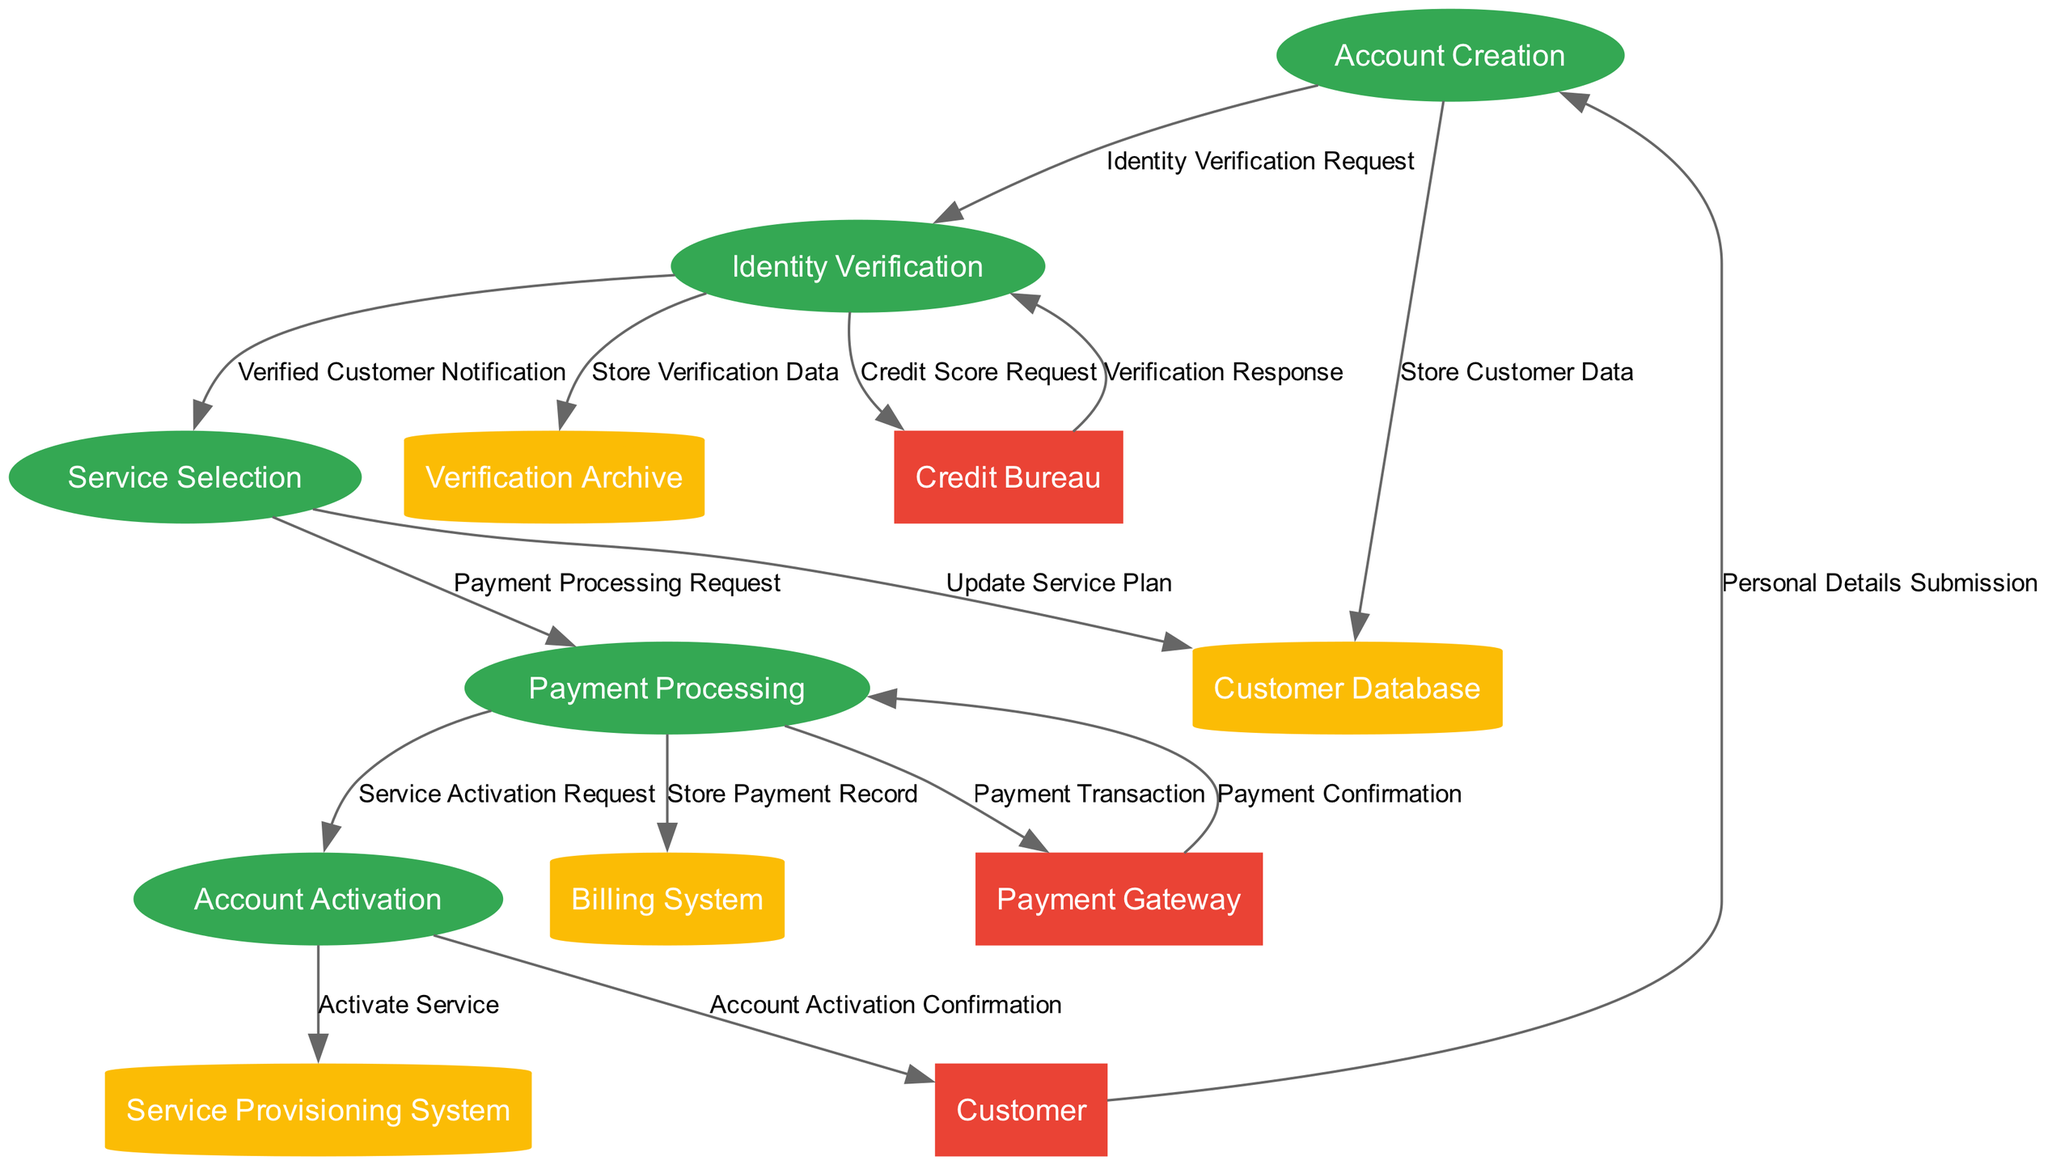What is the first process in the onboarding flow? The first process in the diagram is indicated as the starting node, which is labeled "Account Creation." This process receives input from the external entity "Customer" for account setup.
Answer: Account Creation How many external entities are present in the diagram? By counting the nodes shaped like rectangles that represent external entities, we find three: "Customer," "Payment Gateway," and "Credit Bureau." Thus, the total count is three.
Answer: 3 What type of data store is used to manage payment records? The data store dedicated to managing payment records is described as "Billing System" and has a cylinder shape in the diagram, which signifies a data store.
Answer: Billing System What is the output of the "Payment Processing" process? The output of the "Payment Processing" process is two-fold: it sends a "Payment Confirmation" back to the "Payment Gateway," and also stores the payment transaction details in the "Billing System," indicating multiple outputs.
Answer: Payment Confirmation and Store Payment Record Which process follows the identity verification? Following the "Identity Verification" process, the next process is the "Service Selection," which only occurs if the identity verification is successful, illustrated by the flow between these processes.
Answer: Service Selection What data is stored in the "Verification Archive"? The "Verification Archive" stores the details of the identity verification process, including credit score reports and audit logs. This storage is indicated by the data flow from the "Identity Verification" process.
Answer: Verification data and audit logs What is the last process in the customer onboarding diagram? The last process in the diagram, marked by a flow leading to an external entity, is "Account Activation," which signifies the final step of the onboarding process where the account is confirmed as activated.
Answer: Account Activation Which external entity is responsible for identity verification checks? The external entity that completes identity verification checks, as illustrated in the diagram, is the "Credit Bureau," which provides the necessary credit score and identity verification data.
Answer: Credit Bureau How many processes are involved in total? By counting the nodes labeled as processes, we find five distinct processes: "Account Creation," "Identity Verification," "Service Selection," "Payment Processing," and "Account Activation." Hence, the total number of processes is five.
Answer: 5 